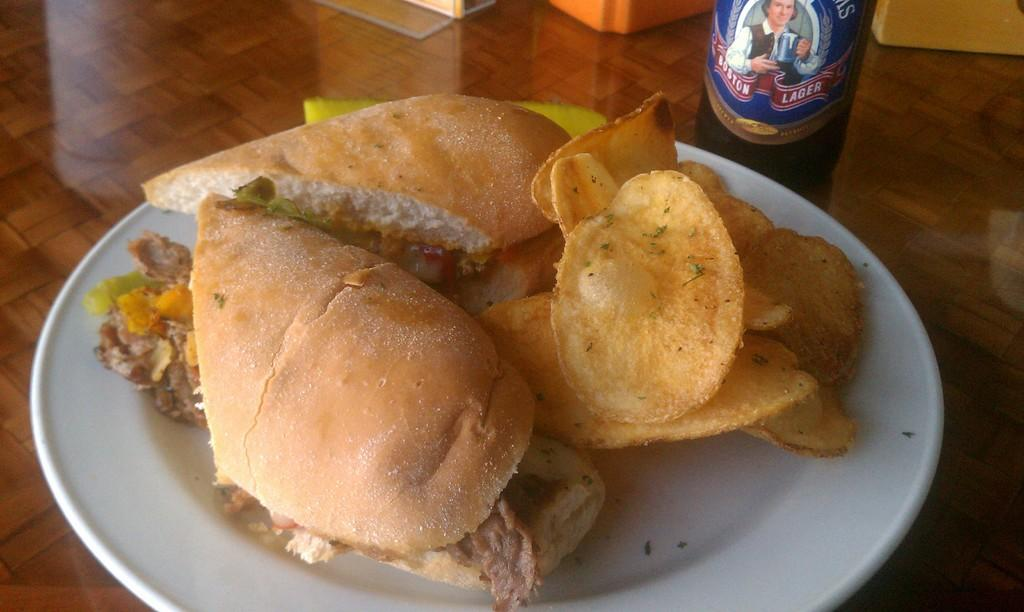What is on the plate that is visible in the image? There is food in a plate in the image. Where is the plate located in the image? The plate is placed on a table. What else can be seen on the table in the image? There is a bottle in the image. What objects are placed beside the bottle in the image? The provided facts do not specify what objects are placed beside the bottle. How many cats are playing with the quince in the image? There are no cats or quince present in the image. Are there any children visible in the image? The provided facts do not mention the presence of children in the image. 